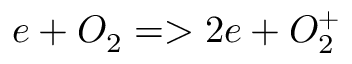Convert formula to latex. <formula><loc_0><loc_0><loc_500><loc_500>e + O _ { 2 } = > 2 e + O _ { 2 } ^ { + }</formula> 